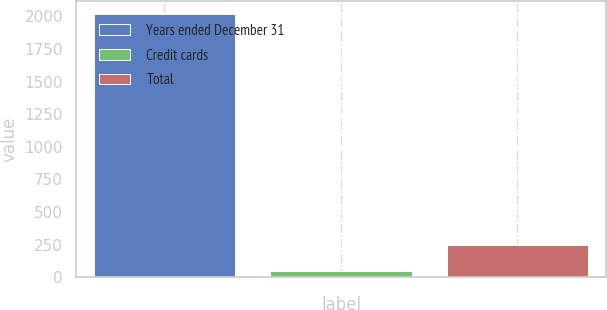Convert chart to OTSL. <chart><loc_0><loc_0><loc_500><loc_500><bar_chart><fcel>Years ended December 31<fcel>Credit cards<fcel>Total<nl><fcel>2015<fcel>49<fcel>245.6<nl></chart> 